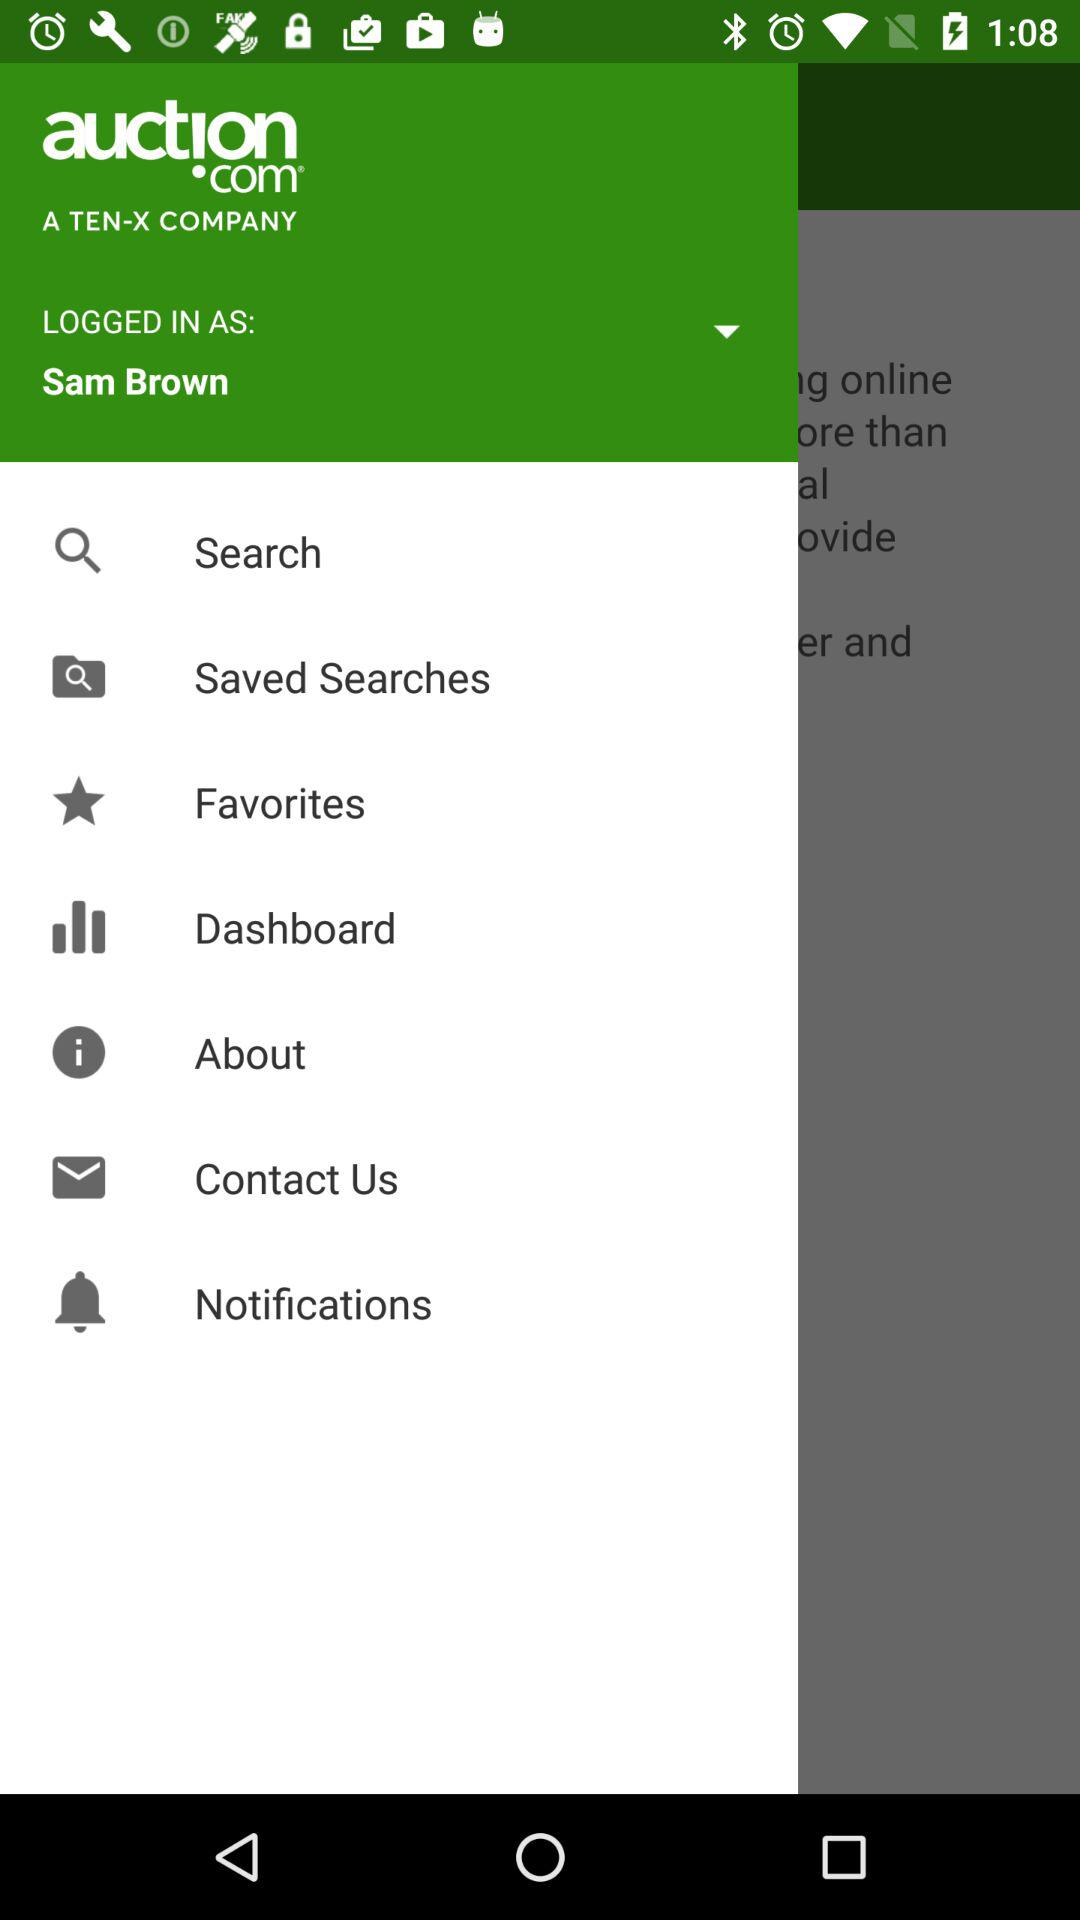What is the name of the user? The name of the user is Sam Brown. 